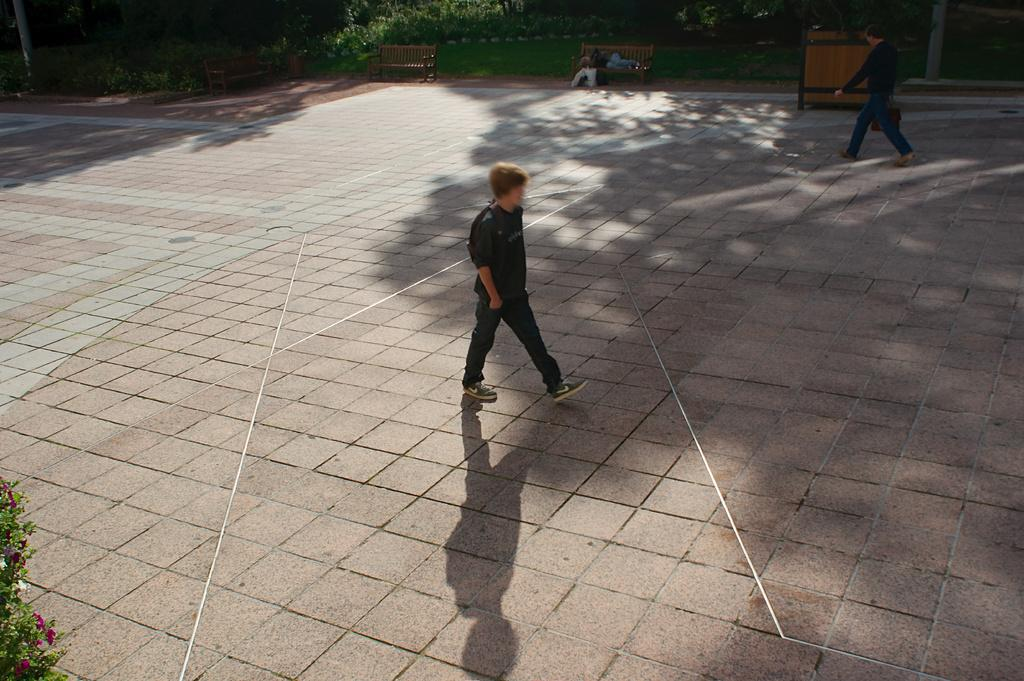What are the two people in the image doing? The two people in the image are walking. On what surface are the people walking? The people are walking on the floor. What type of seating is present in the image? There are two benches in the image. What can be seen in the image besides the people and benches? There are plants visible in the image. How is the water distributed among the plants in the image? There is no water present in the image, so it cannot be distributed among the plants. 